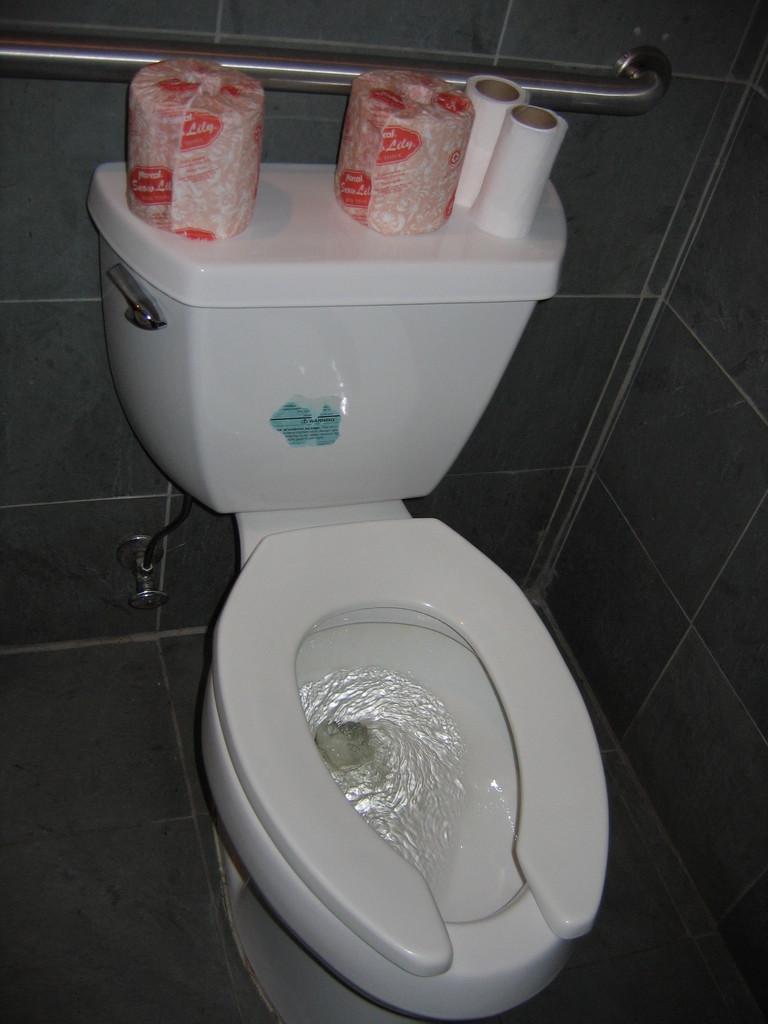Can you describe this image briefly? In this image there is a toilet and there are some tissue papers, stand, tap and wall. 